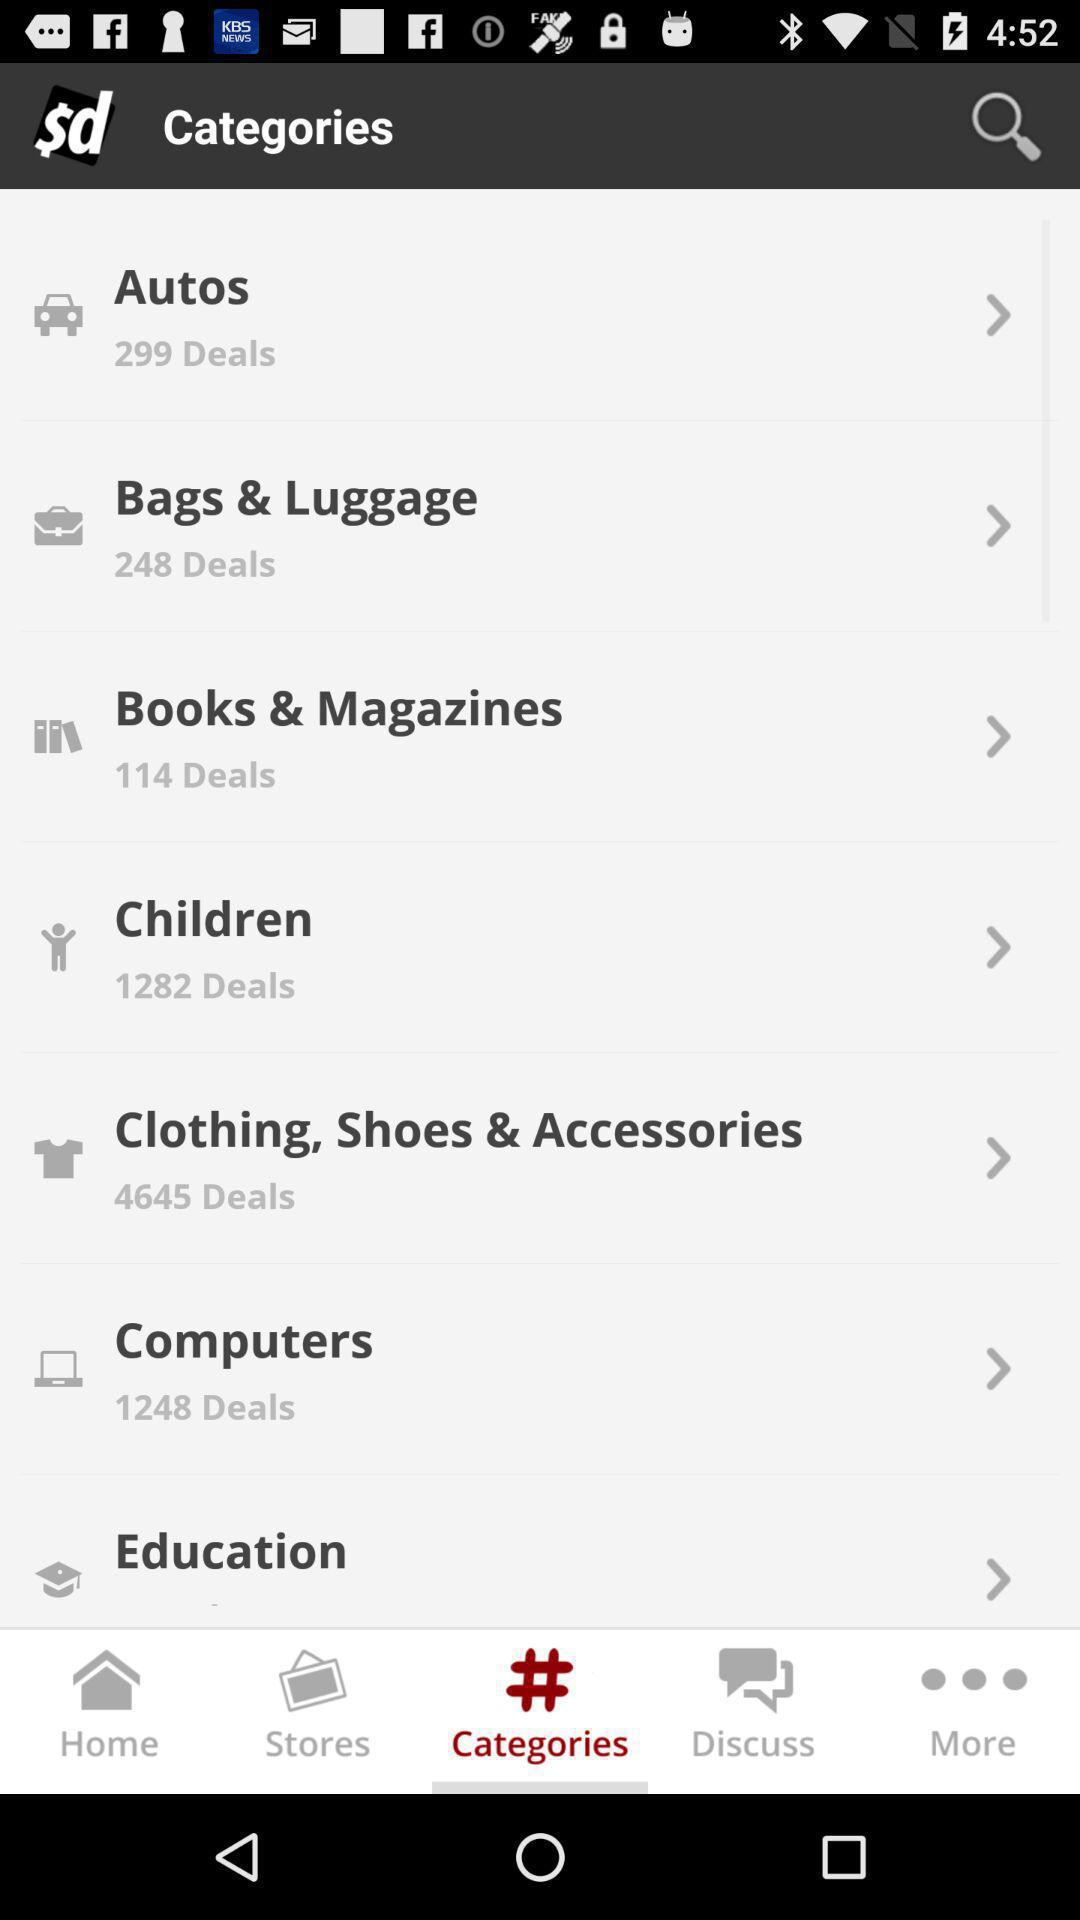How many deals are there in "Children"? There are 1282 deals. 